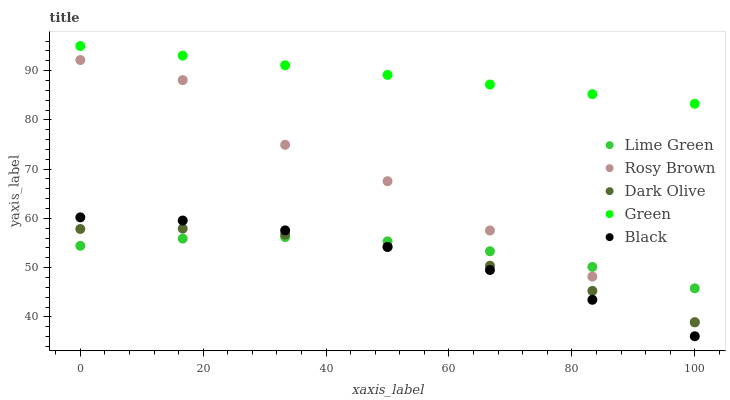Does Black have the minimum area under the curve?
Answer yes or no. Yes. Does Green have the maximum area under the curve?
Answer yes or no. Yes. Does Rosy Brown have the minimum area under the curve?
Answer yes or no. No. Does Rosy Brown have the maximum area under the curve?
Answer yes or no. No. Is Green the smoothest?
Answer yes or no. Yes. Is Rosy Brown the roughest?
Answer yes or no. Yes. Is Rosy Brown the smoothest?
Answer yes or no. No. Is Green the roughest?
Answer yes or no. No. Does Black have the lowest value?
Answer yes or no. Yes. Does Rosy Brown have the lowest value?
Answer yes or no. No. Does Green have the highest value?
Answer yes or no. Yes. Does Rosy Brown have the highest value?
Answer yes or no. No. Is Black less than Rosy Brown?
Answer yes or no. Yes. Is Rosy Brown greater than Dark Olive?
Answer yes or no. Yes. Does Rosy Brown intersect Lime Green?
Answer yes or no. Yes. Is Rosy Brown less than Lime Green?
Answer yes or no. No. Is Rosy Brown greater than Lime Green?
Answer yes or no. No. Does Black intersect Rosy Brown?
Answer yes or no. No. 